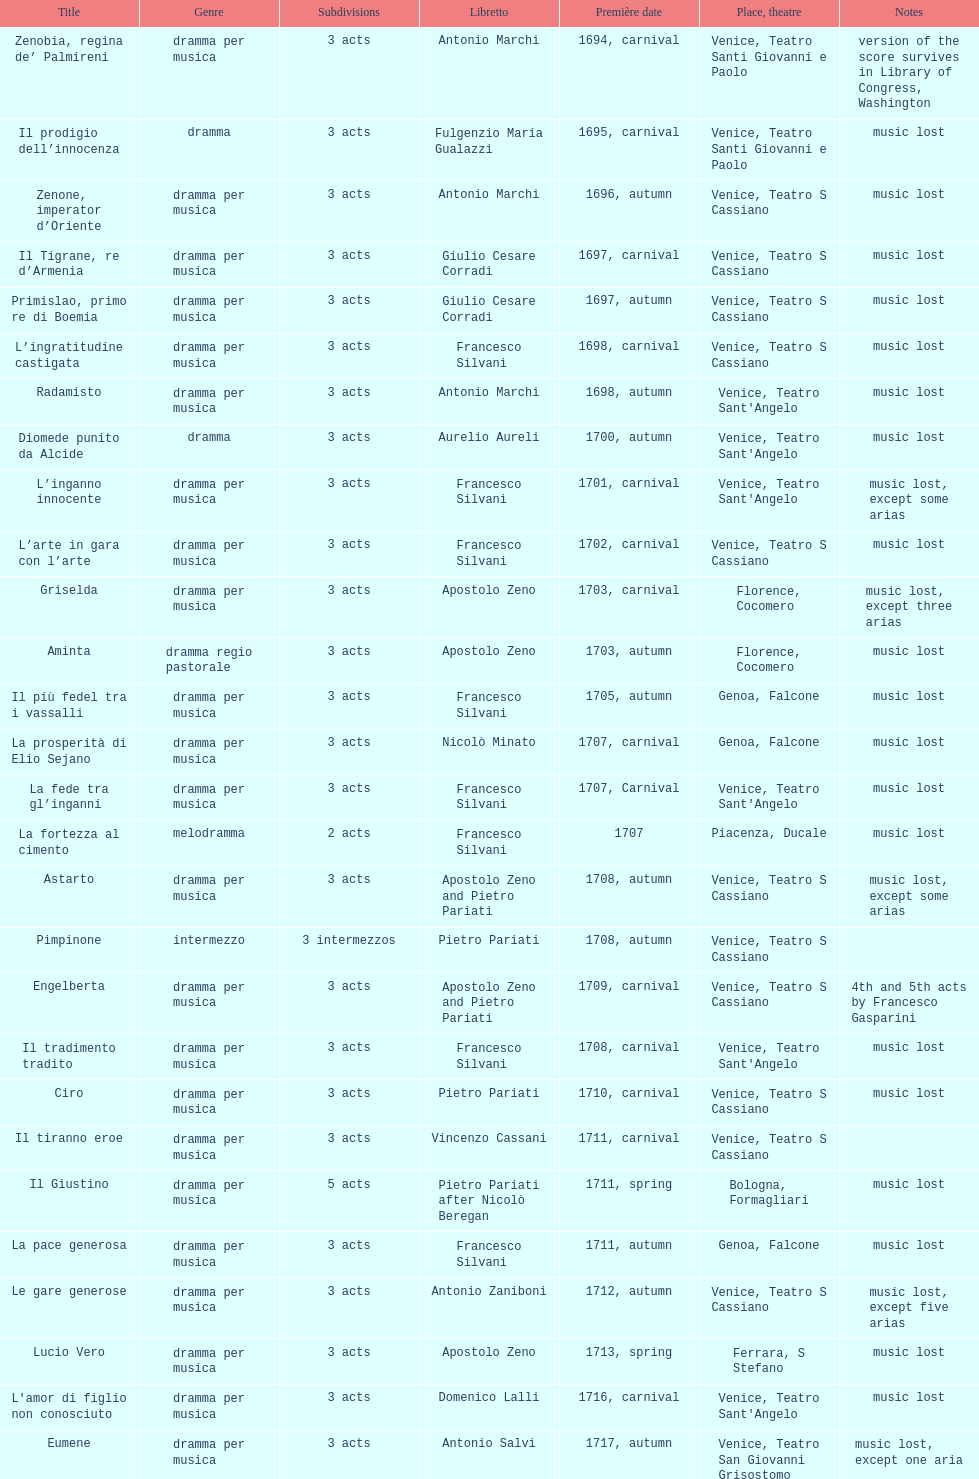What is the count of acts in il giustino? 5. 